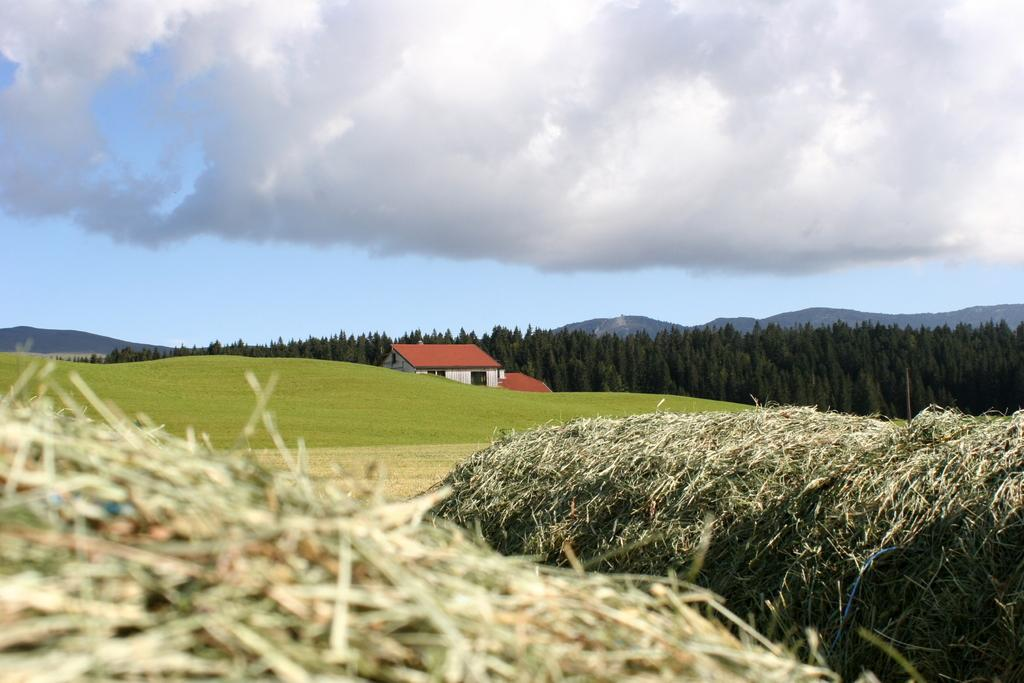What type of vegetation can be seen in the image? There is grass in the image. What is the setting of the background in the image? There is a grass lawn, a house with windows, trees, hills, and the sky visible in the background of the image. Can you describe the sky in the image? The sky is visible in the background of the image, and clouds are present. What type of hat is the clover wearing in the image? There is no clover or hat present in the image. How does the grip of the tree affect the appearance of the grass in the image? There is no mention of a grip or any interaction between the tree and grass in the image. 